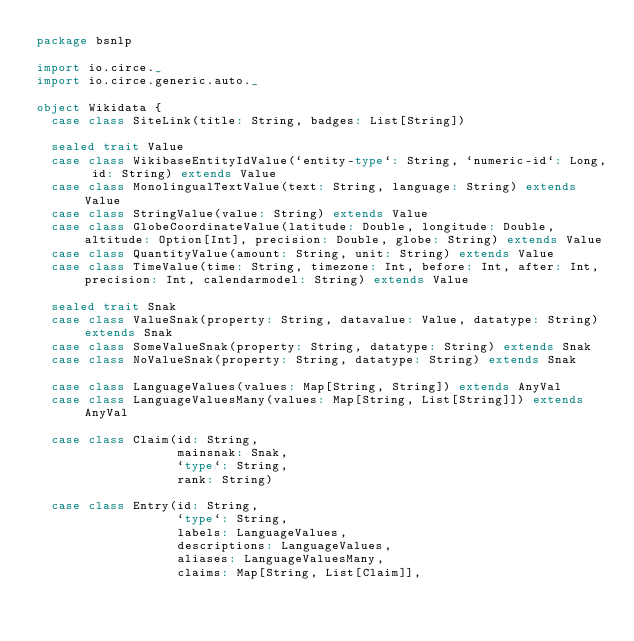<code> <loc_0><loc_0><loc_500><loc_500><_Scala_>package bsnlp

import io.circe._
import io.circe.generic.auto._

object Wikidata {
  case class SiteLink(title: String, badges: List[String])

  sealed trait Value
  case class WikibaseEntityIdValue(`entity-type`: String, `numeric-id`: Long, id: String) extends Value
  case class MonolingualTextValue(text: String, language: String) extends Value
  case class StringValue(value: String) extends Value
  case class GlobeCoordinateValue(latitude: Double, longitude: Double, altitude: Option[Int], precision: Double, globe: String) extends Value
  case class QuantityValue(amount: String, unit: String) extends Value
  case class TimeValue(time: String, timezone: Int, before: Int, after: Int, precision: Int, calendarmodel: String) extends Value

  sealed trait Snak
  case class ValueSnak(property: String, datavalue: Value, datatype: String) extends Snak
  case class SomeValueSnak(property: String, datatype: String) extends Snak
  case class NoValueSnak(property: String, datatype: String) extends Snak

  case class LanguageValues(values: Map[String, String]) extends AnyVal
  case class LanguageValuesMany(values: Map[String, List[String]]) extends AnyVal

  case class Claim(id: String,
                   mainsnak: Snak,
                   `type`: String,
                   rank: String)

  case class Entry(id: String,
                   `type`: String,
                   labels: LanguageValues,
                   descriptions: LanguageValues,
                   aliases: LanguageValuesMany,
                   claims: Map[String, List[Claim]],</code> 